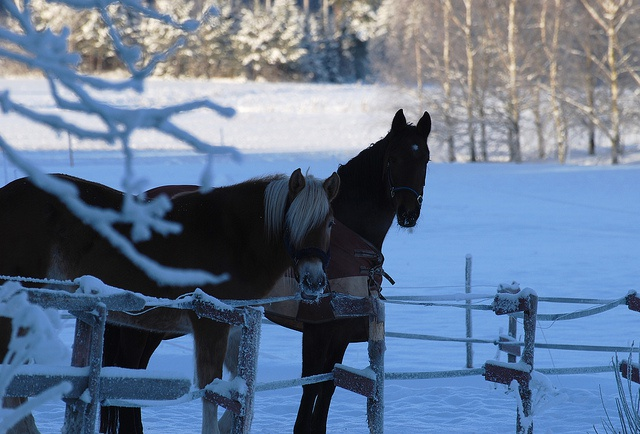Describe the objects in this image and their specific colors. I can see horse in blue, black, gray, and navy tones and horse in blue, black, gray, and darkgray tones in this image. 